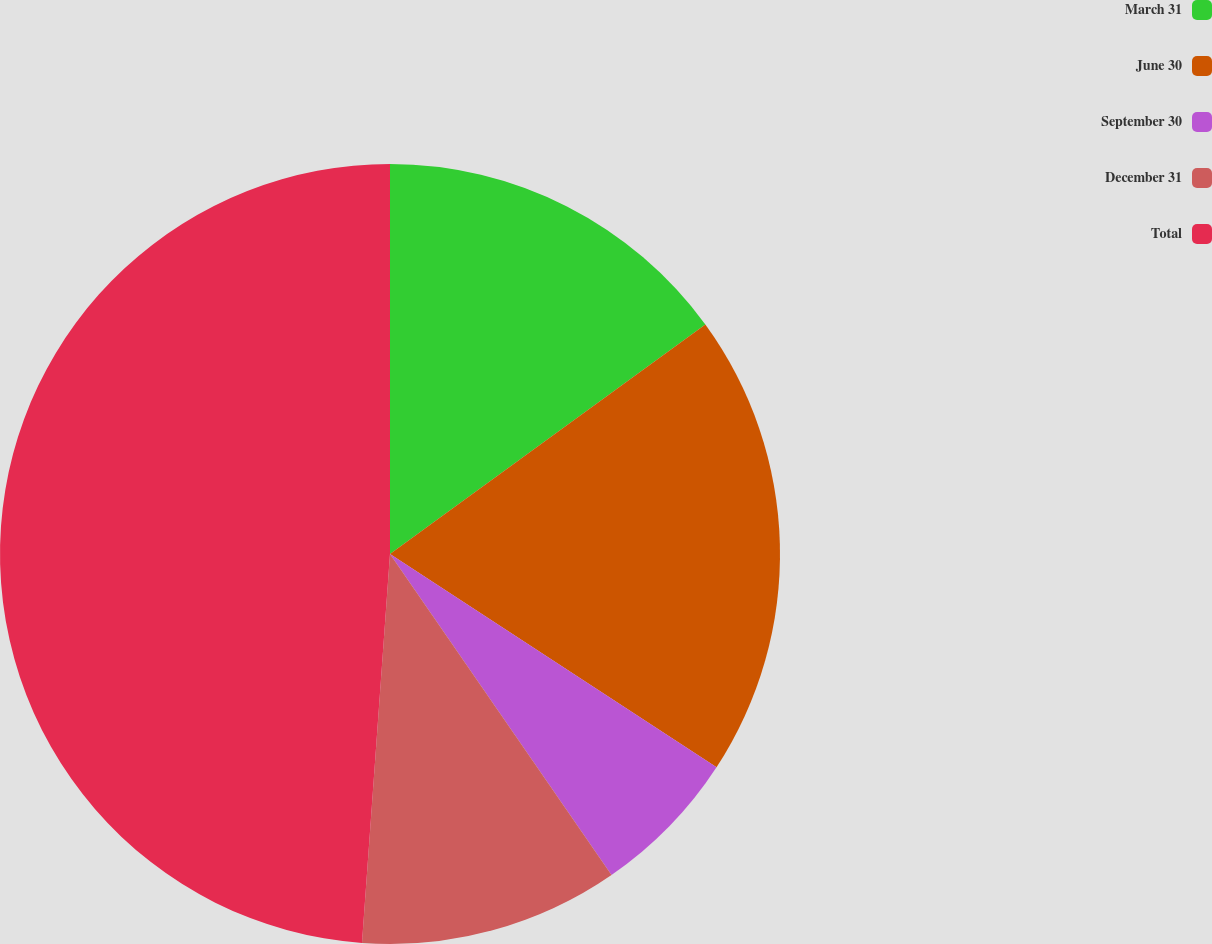<chart> <loc_0><loc_0><loc_500><loc_500><pie_chart><fcel>March 31<fcel>June 30<fcel>September 30<fcel>December 31<fcel>Total<nl><fcel>14.99%<fcel>19.22%<fcel>6.18%<fcel>10.76%<fcel>48.86%<nl></chart> 